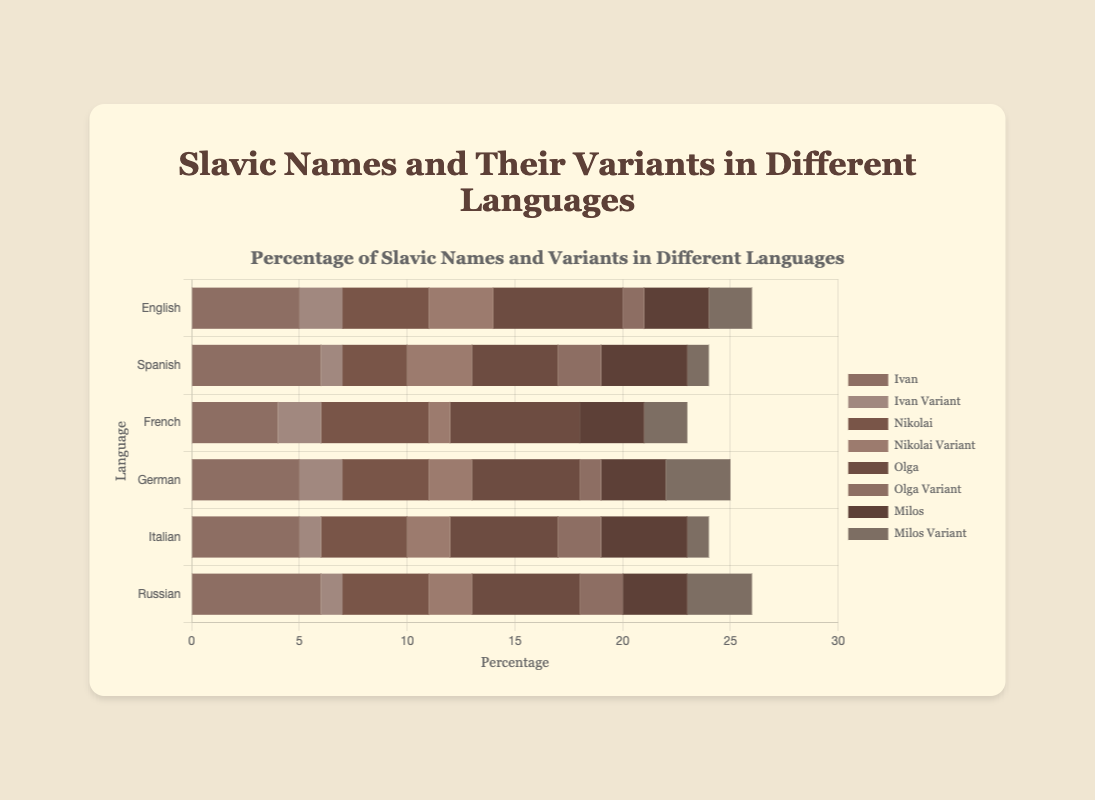Which language has the highest percentage of the name 'Ivan'? By looking at the length of the bars representing 'Ivan' in different languages, we see that 'Russian' and 'Spanish' both have the longest bars. Specifically, the 'Ivan' bar reaches 6 units for both. Hence, the longest bars indicating the highest percentage of 'Ivan' are in Russian and Spanish.
Answer: Russian and Spanish In which language adaptation is the name 'Olga' most and least prevalent? To determine the prevalence, we look at the length of the 'Olga' bars across different languages. The lengths are as follows: English (6), Spanish (4), French (6), German (5), Italian (5), Russian (5). The longest 'Olga' bars are for English and French, and the shortest 'Olga' bar is for Spanish.
Answer: Most: English and French; Least: Spanish What is the total percentage of 'Nikolai' and its variant in French? To find the total, we sum the lengths of the 'Nikolai' and 'Nikolai Variant' bars for French. These are 5 (Nikolai) and 1 (Nikolai Variant), so the total is 5 + 1.
Answer: 6 Which variant (Nikolai or Ivan) has a higher percentage in German? To find this, compare the lengths of 'Nikolai Variant' and 'Ivan Variant' bars in German: 'Nikolai Variant' is 2 and 'Ivan Variant' also is 2. They are equal in percentage.
Answer: Equal What is the combined percentage of 'Milos' and its variant in Spanish and Italian? For Spanish: 'Milos' is 4, 'Milos Variant' is 1. For Italian: 'Milos' is 4, 'Milos Variant' is 1. Combine these to get the total percentage in Spanish (4 + 1 = 5) and Italian (4 + 1 = 5). Adding both totals, we get 5 + 5.
Answer: 10 In which language adaptations do both 'Olga' and 'Olga Variant' together sum up to exactly 7%? Calculate the sum of the bars for 'Olga' and 'Olga Variant' in each language: English (6 + 1), Spanish (4 + 2), French (6 + 0), German (5 + 1), Italian (5 + 2), Russian (5 + 2). The sums are: English (7), Spanish (6), French (6), German (6), Italian (7), and Russian (7). Hence, English, Italian, and Russian have an exact sum of 7.
Answer: English, Italian, and Russian 